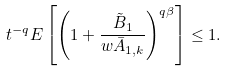Convert formula to latex. <formula><loc_0><loc_0><loc_500><loc_500>t ^ { - q } { E } \left [ \left ( 1 + \frac { \tilde { B } _ { 1 } } { w \bar { A } _ { 1 , k } } \right ) ^ { q \beta } \right ] \leq 1 .</formula> 